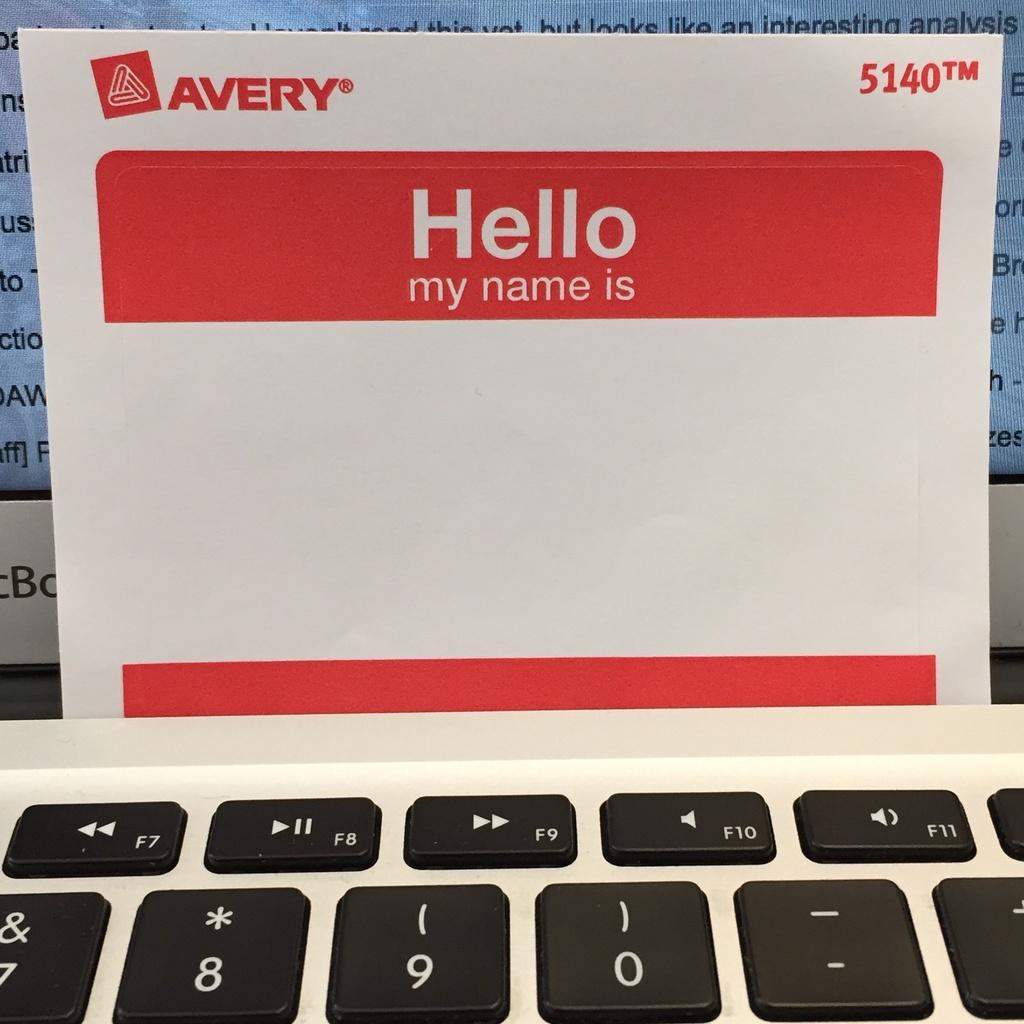<image>
Create a compact narrative representing the image presented. A "Hello my name is" sticker with no name on it 